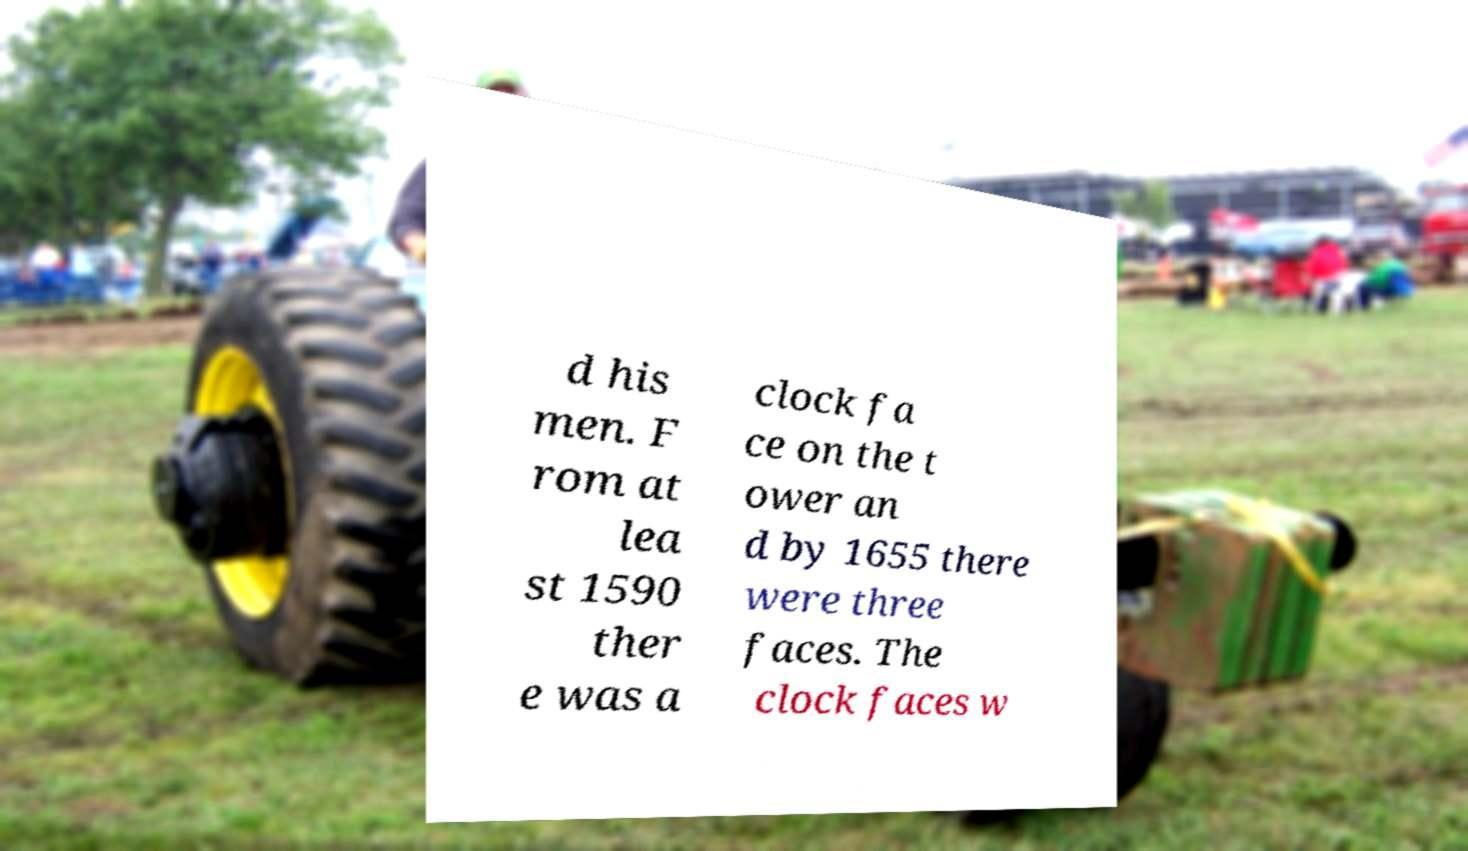For documentation purposes, I need the text within this image transcribed. Could you provide that? d his men. F rom at lea st 1590 ther e was a clock fa ce on the t ower an d by 1655 there were three faces. The clock faces w 